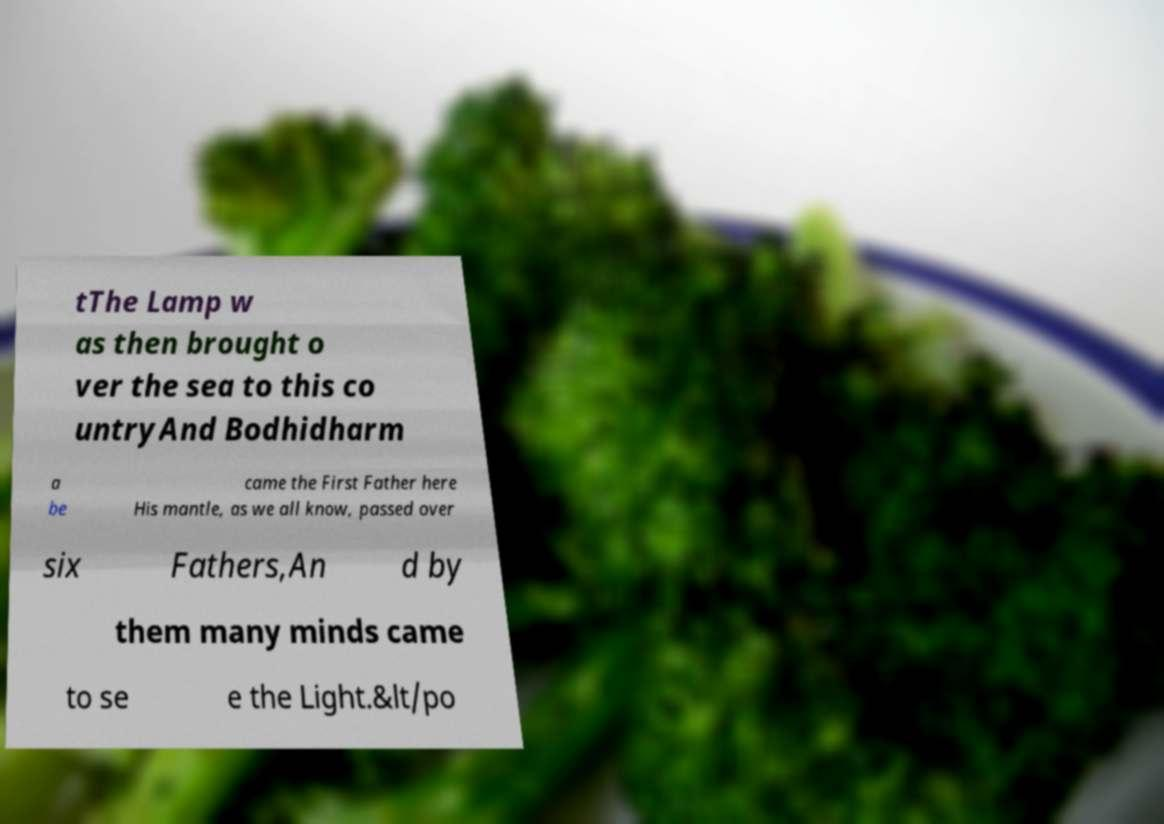What messages or text are displayed in this image? I need them in a readable, typed format. tThe Lamp w as then brought o ver the sea to this co untryAnd Bodhidharm a be came the First Father here His mantle, as we all know, passed over six Fathers,An d by them many minds came to se e the Light.&lt/po 